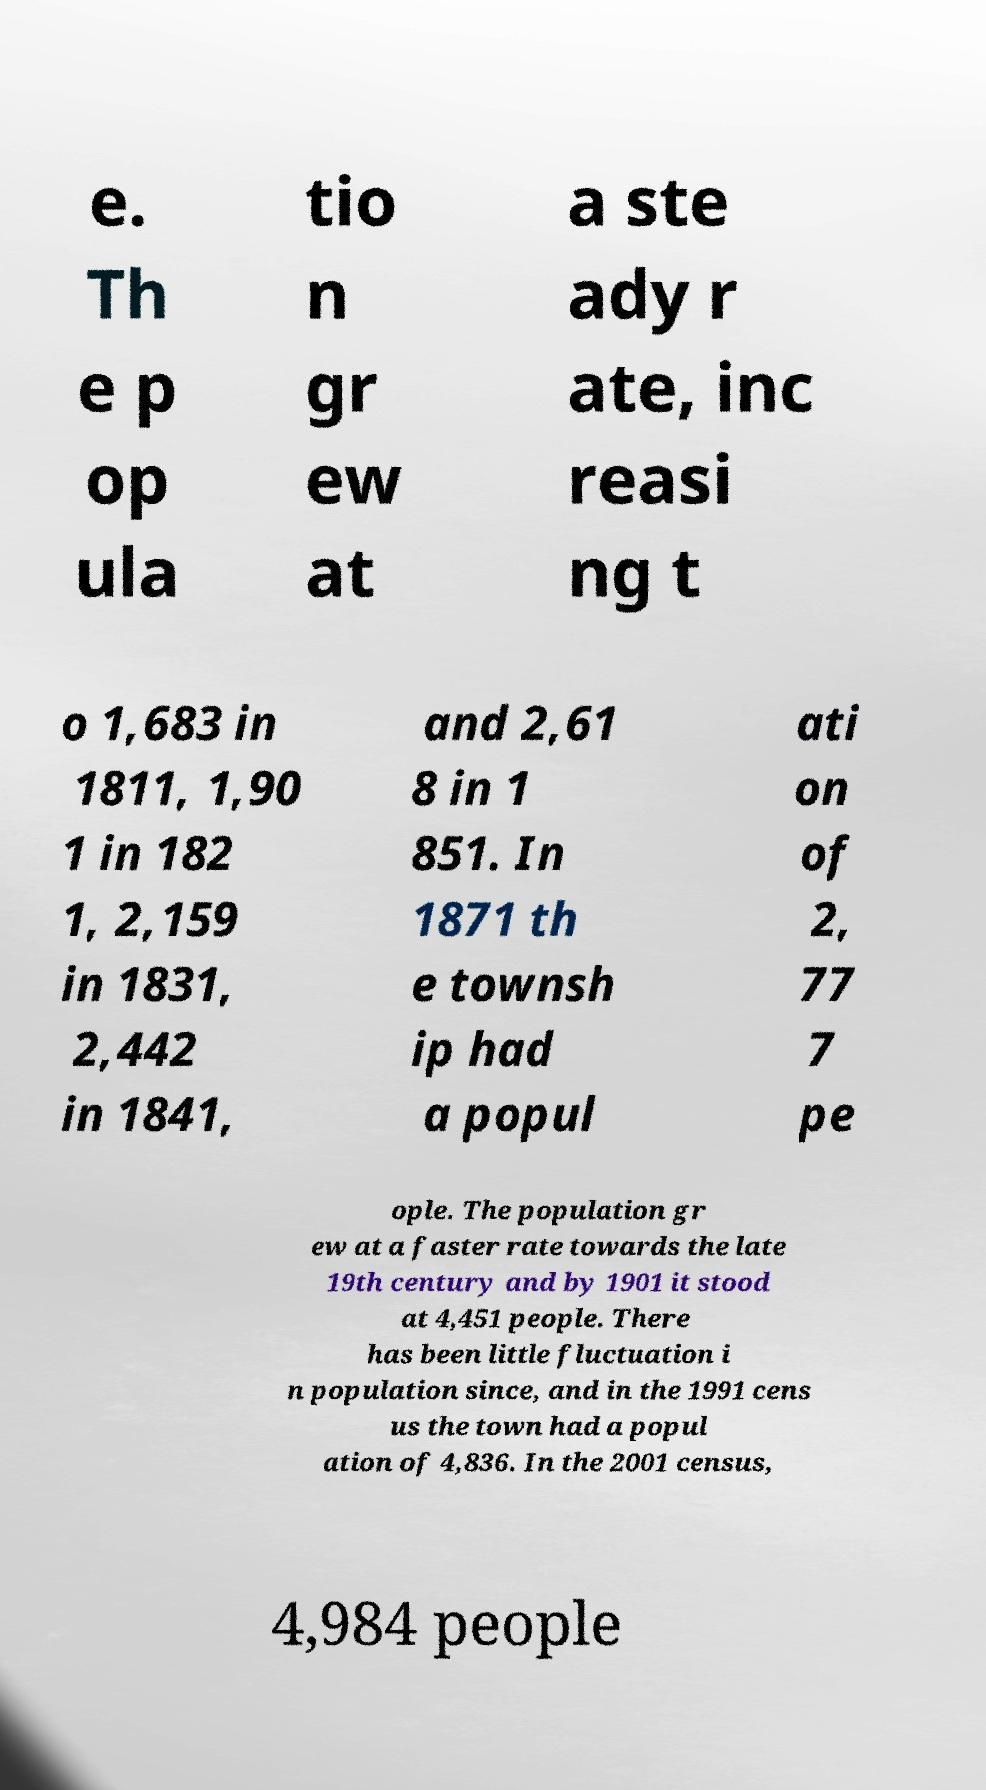Please identify and transcribe the text found in this image. e. Th e p op ula tio n gr ew at a ste ady r ate, inc reasi ng t o 1,683 in 1811, 1,90 1 in 182 1, 2,159 in 1831, 2,442 in 1841, and 2,61 8 in 1 851. In 1871 th e townsh ip had a popul ati on of 2, 77 7 pe ople. The population gr ew at a faster rate towards the late 19th century and by 1901 it stood at 4,451 people. There has been little fluctuation i n population since, and in the 1991 cens us the town had a popul ation of 4,836. In the 2001 census, 4,984 people 